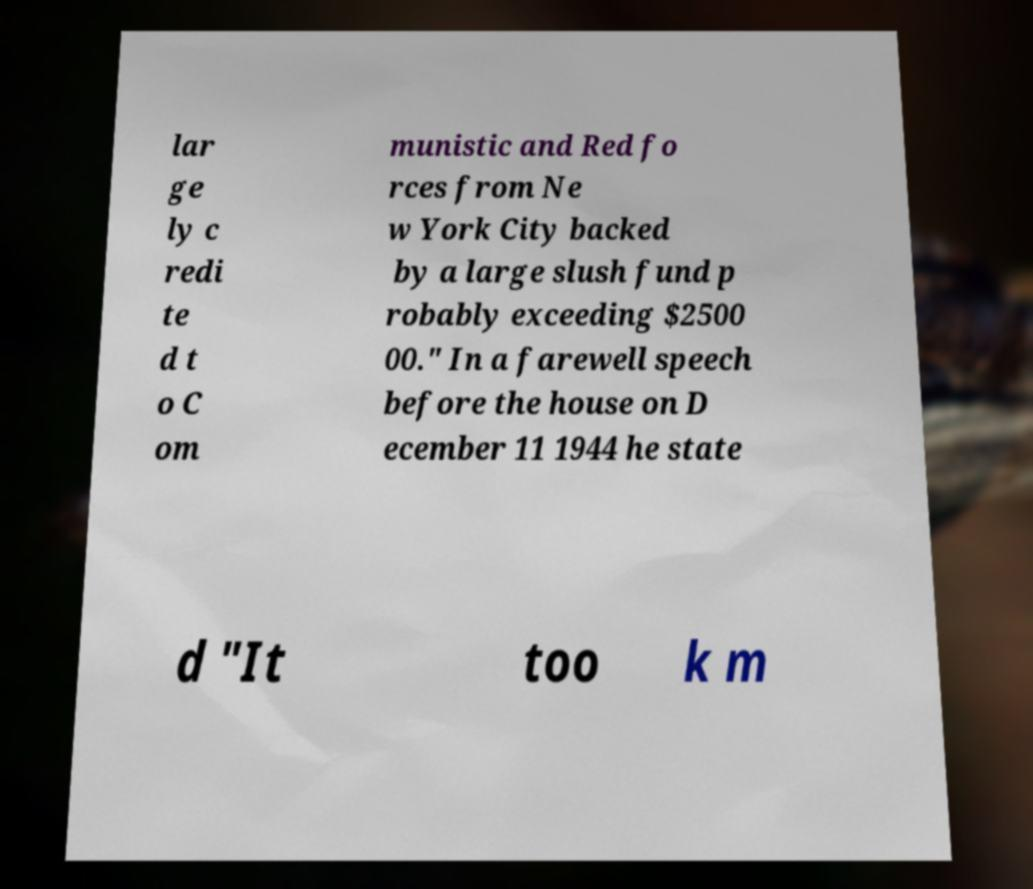Could you extract and type out the text from this image? lar ge ly c redi te d t o C om munistic and Red fo rces from Ne w York City backed by a large slush fund p robably exceeding $2500 00." In a farewell speech before the house on D ecember 11 1944 he state d "It too k m 